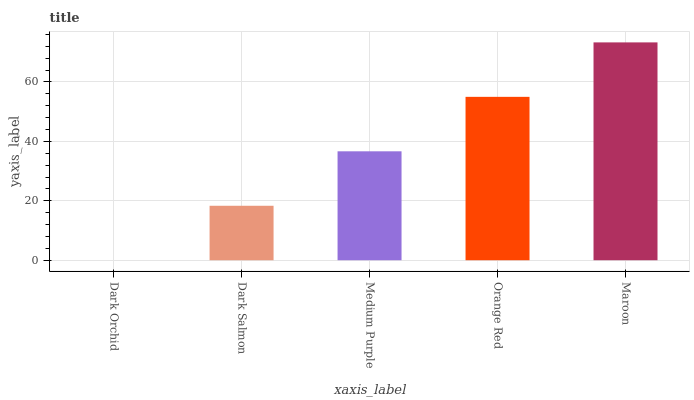Is Dark Salmon the minimum?
Answer yes or no. No. Is Dark Salmon the maximum?
Answer yes or no. No. Is Dark Salmon greater than Dark Orchid?
Answer yes or no. Yes. Is Dark Orchid less than Dark Salmon?
Answer yes or no. Yes. Is Dark Orchid greater than Dark Salmon?
Answer yes or no. No. Is Dark Salmon less than Dark Orchid?
Answer yes or no. No. Is Medium Purple the high median?
Answer yes or no. Yes. Is Medium Purple the low median?
Answer yes or no. Yes. Is Dark Orchid the high median?
Answer yes or no. No. Is Dark Salmon the low median?
Answer yes or no. No. 